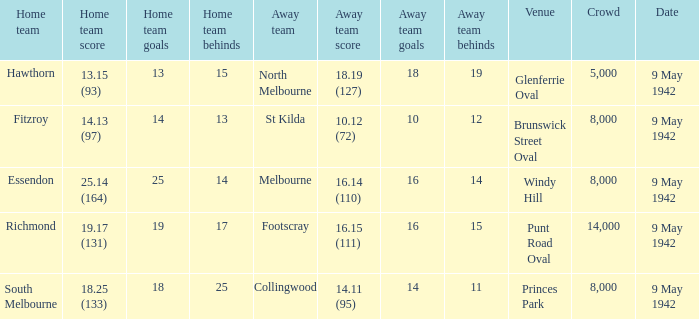How big was the audience when the home team achieved a score of 18.25 (133)? 8000.0. 